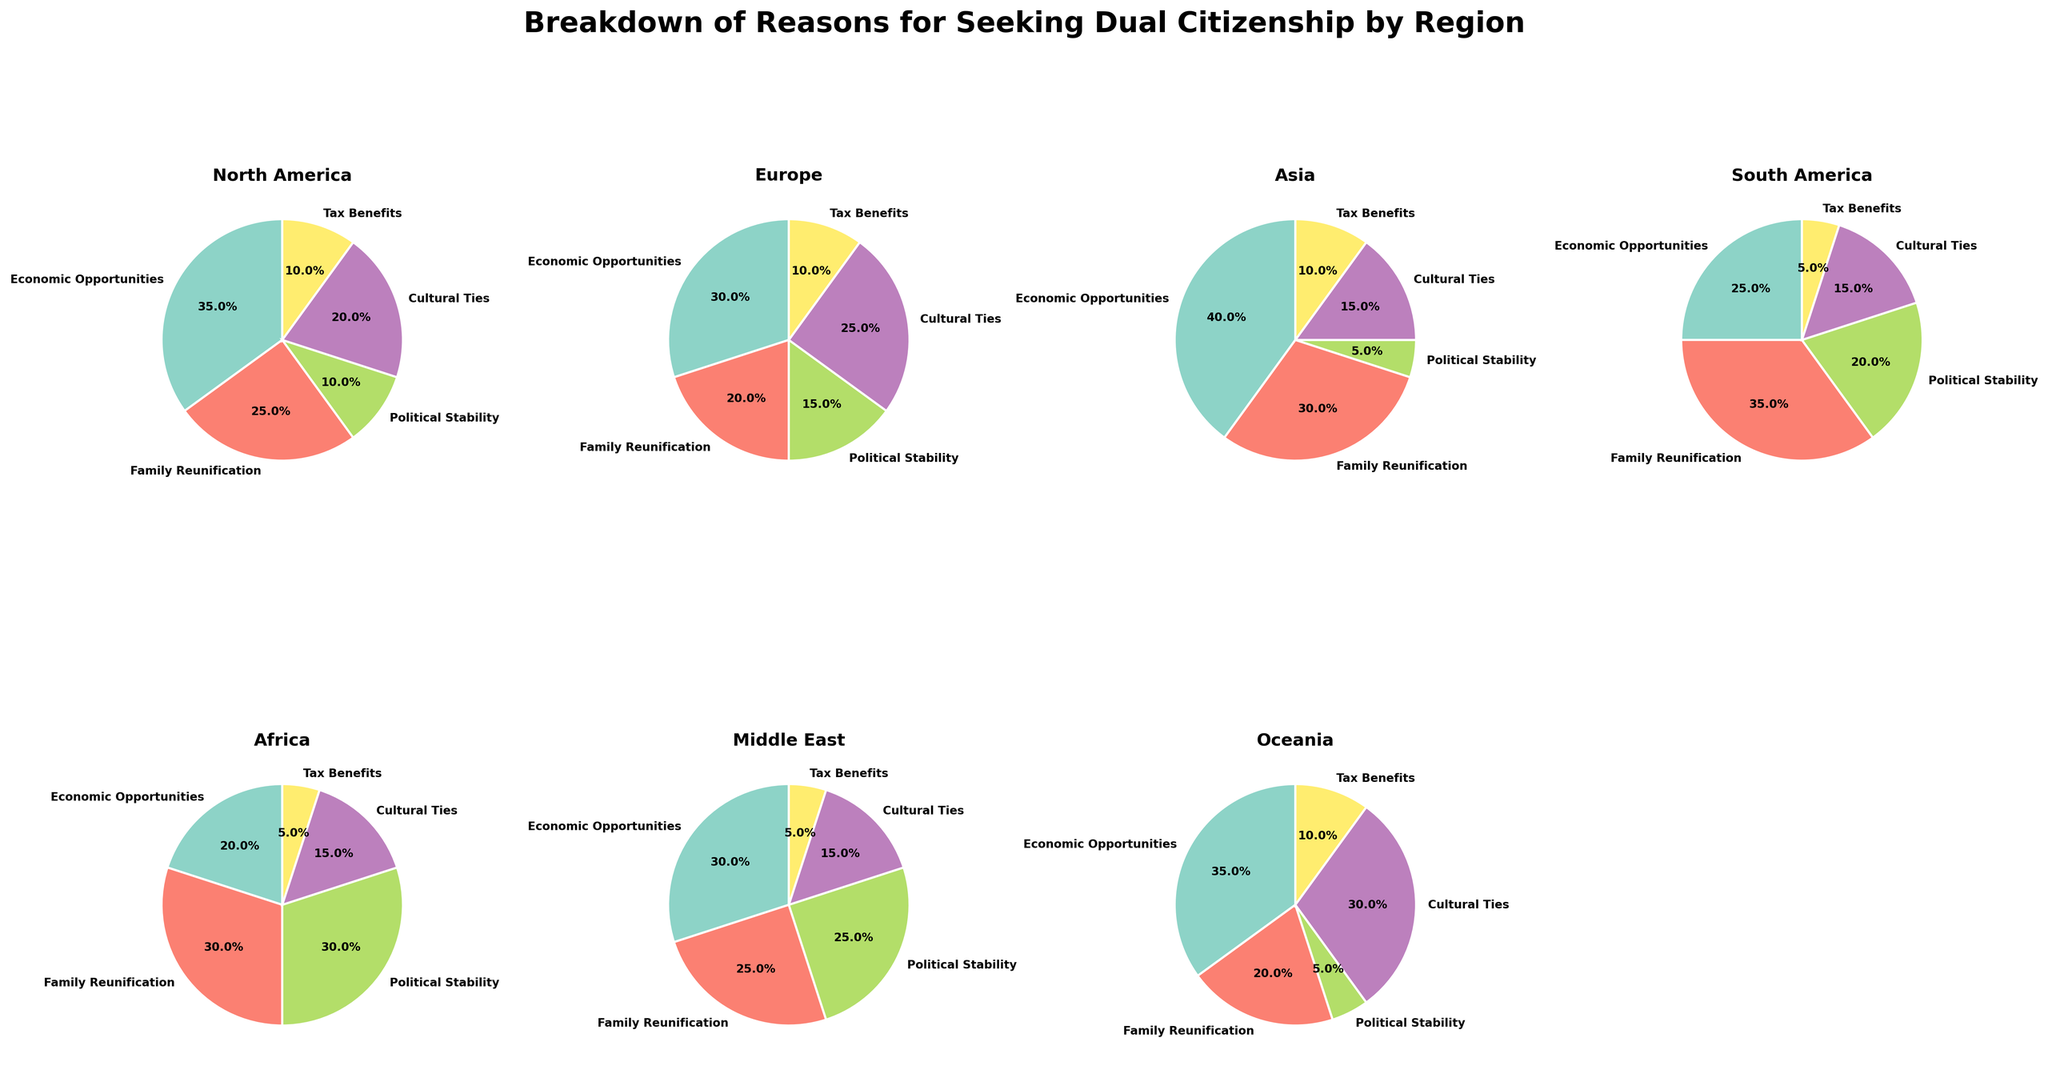What are the main reasons for seeking dual citizenship in North America? The chart for North America shows the breakdown of reasons for seeking dual citizenship. Economic Opportunities (35%) and Family Reunification (25%) are the main reasons, followed by Cultural Ties (20%), Political Stability (10%), and Tax Benefits (10%).
Answer: Economic Opportunities and Family Reunification Which region has the highest percentage of people seeking dual citizenship due to Political Stability? To identify the region with the highest percentage for Political Stability, compare the pie chart segments labeled "Political Stability" across all regions. Africa stands out with 30%.
Answer: Africa What is the combined percentage of people seeking dual citizenship for Cultural Ties in Europe and Oceania? The figure shows Europe with 25% and Oceania with 30% for Cultural Ties. Adding 25% + 30% gives the combined percentage.
Answer: 55% Between Asia and South America, which region has a higher percentage for Family Reunification? By examining the “Family Reunification” segments, Asia has 30%, and South America has 35%.
Answer: South America Which reason for seeking dual citizenship is least represented in the Middle East? The smallest segment in the Middle East chart is Tax Benefits, with 5%.
Answer: Tax Benefits How does the percentage for Economic Opportunities in Africa compare to North America? Comparatively, North America's chart shows 35% for Economic Opportunities, while Africa’s chart shows 20%. Therefore, North America has a higher percentage.
Answer: North America has a higher percentage What percentage of people in Asia seek dual citizenship due to Cultural Ties? Looking at the pie chart for Asia, the segment for Cultural Ties is marked as 15%.
Answer: 15% If you combine the percentages of people seeking dual citizenship for Family Reunification in South America and the Middle East, what would that total be? The chart shows South America with 35% and the Middle East with 25% for Family Reunification. Adding 35% + 25% gives a total of 60%.
Answer: 60% Which region has the narrowest segment for Political Stability and what is the percentage? Observing the "Political Stability" segments, Asia has the narrowest with 5%.
Answer: Asia, 5% 